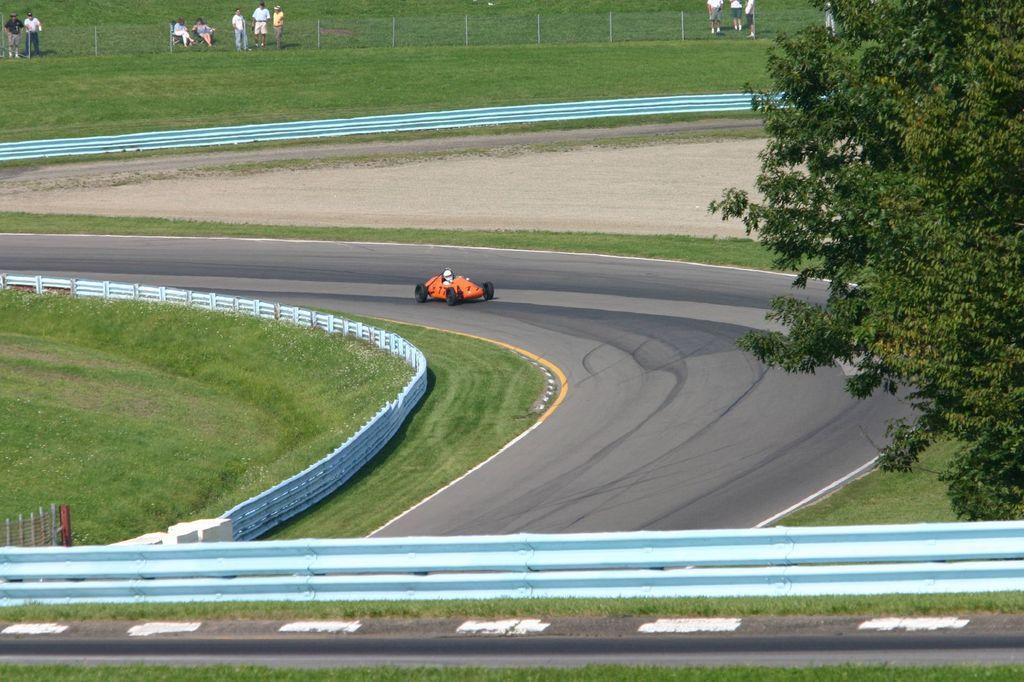Can you describe this image briefly? In the center of the image we can see a person riding an open wheel car on the road. At the bottom there is a fence. On the right there is a tree. In the background there are people. 